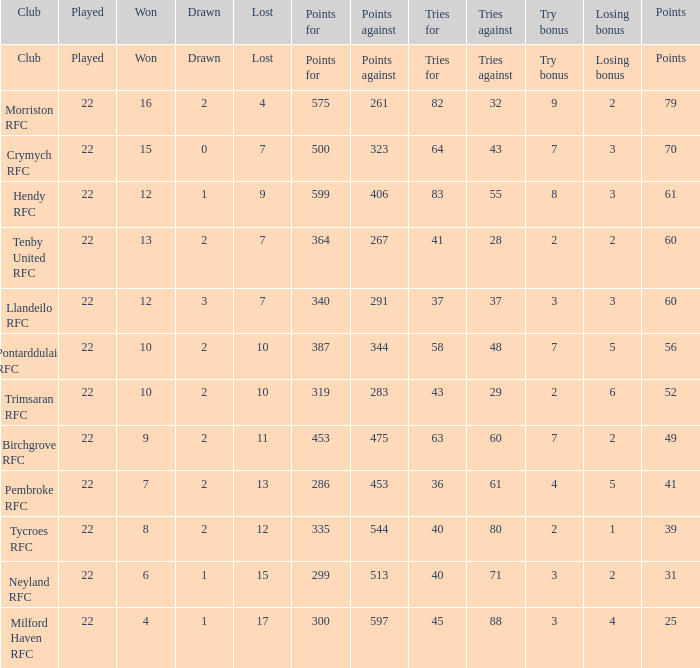What is the number of losing bonuses when there are 10 wins and 283 points against? 1.0. 